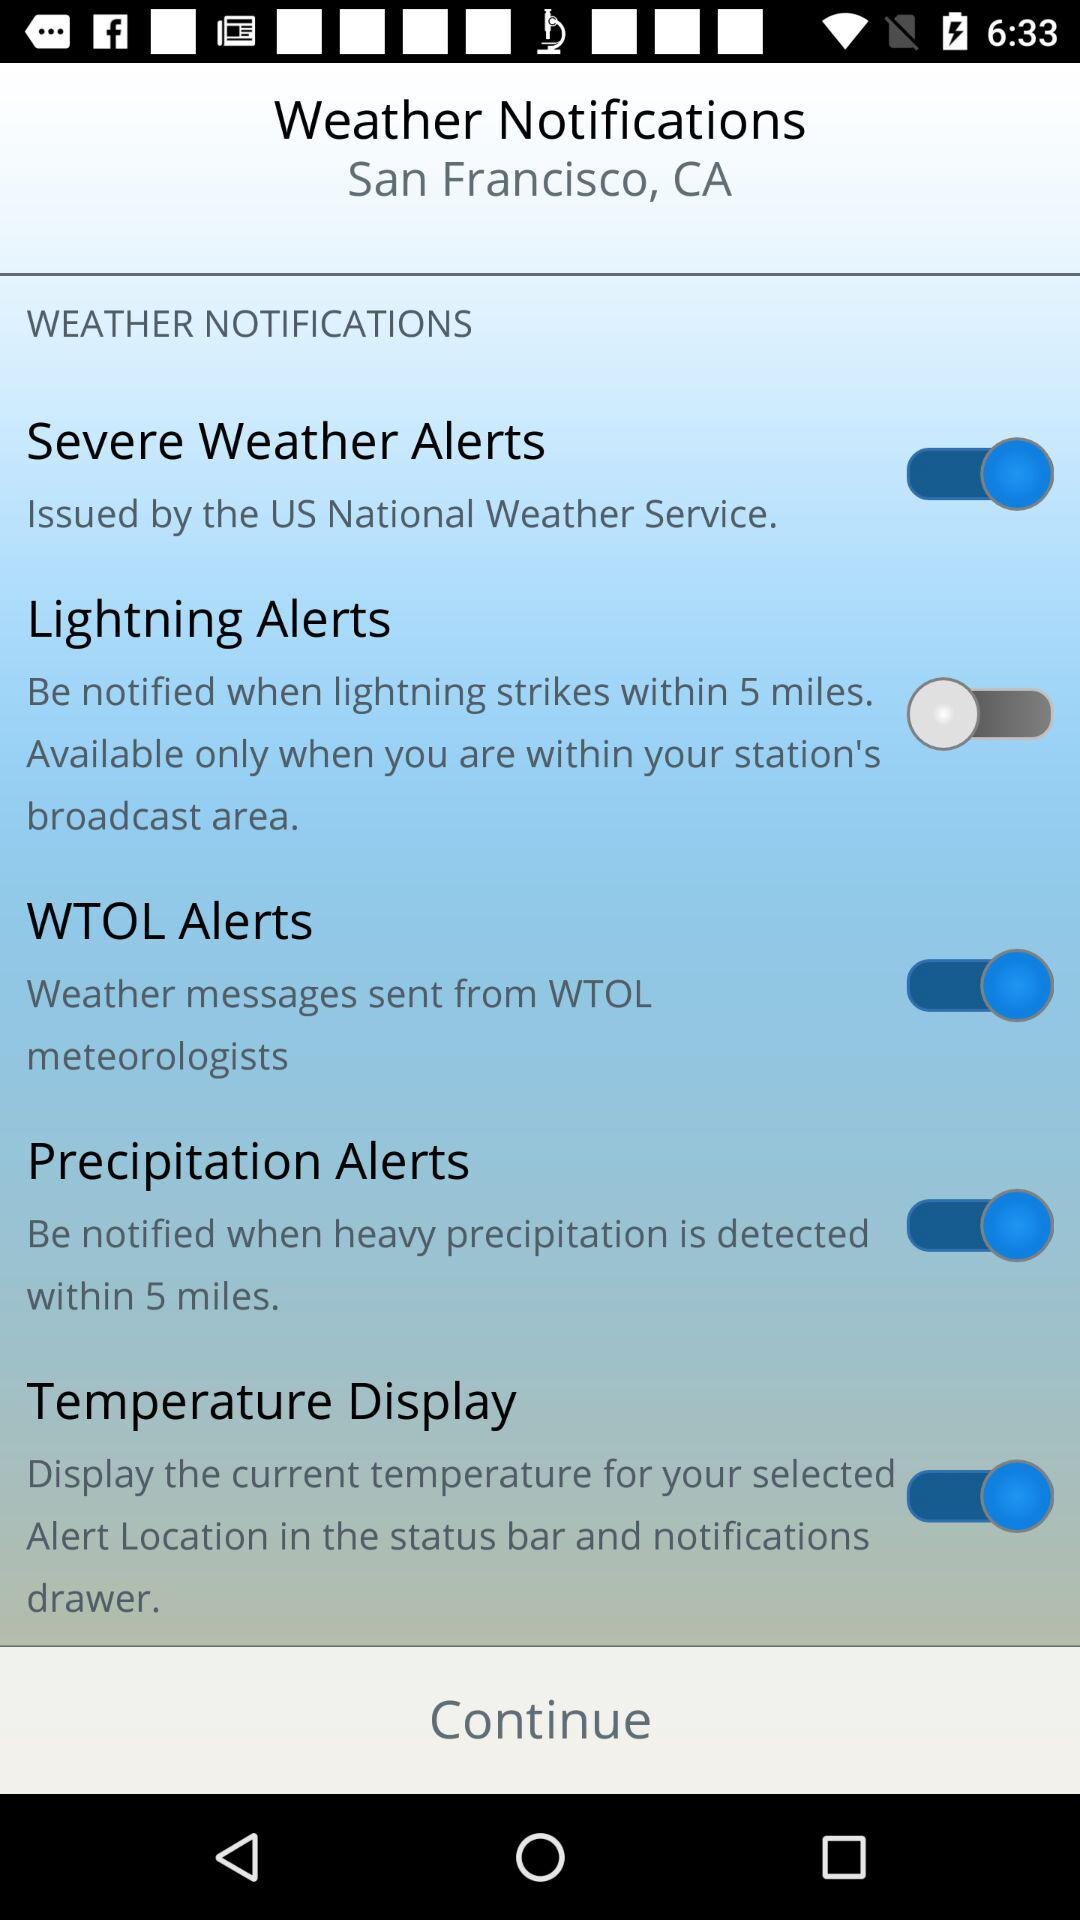What is the status of the "WTOL Alerts"? The status is "off". 